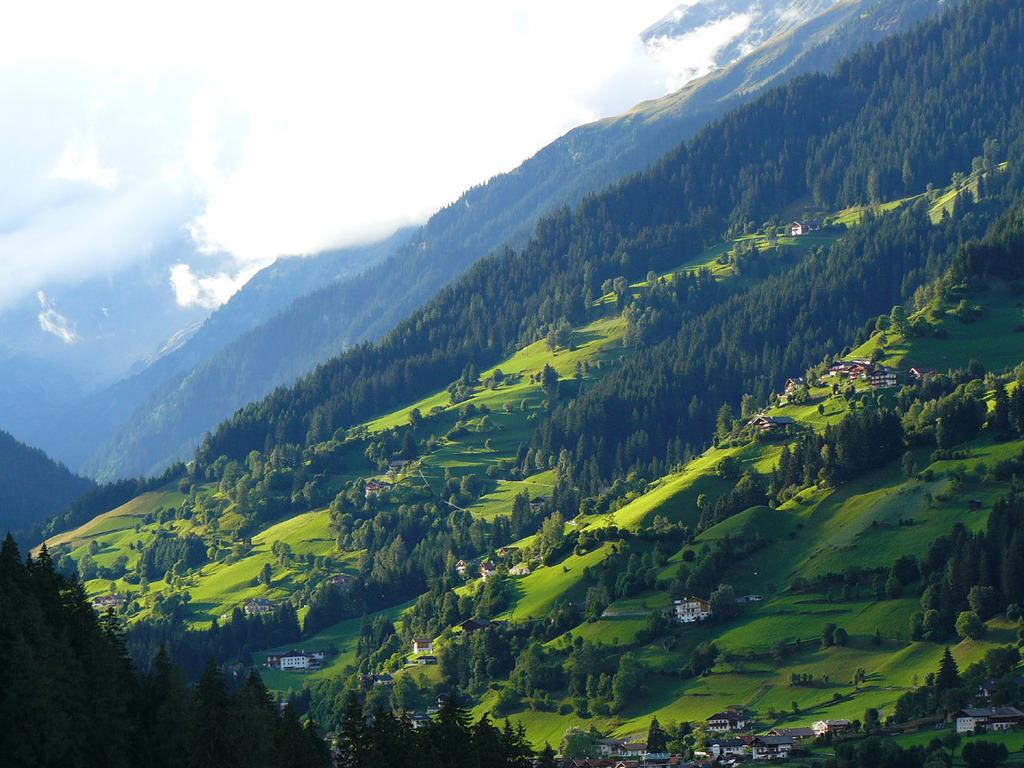What type of structures can be seen in the image? There are houses in the image. What other natural elements are present in the image? There are trees and mountains in the image. What is visible in the background of the image? The sky is visible in the background of the image. What can be observed in the sky? Clouds are present in the sky. Where is the kettle located in the image? There is no kettle present in the image. What type of shade is provided by the trees in the image? There is no mention of shade in the image, as the focus is on the houses, trees, mountains, sky, and clouds. 